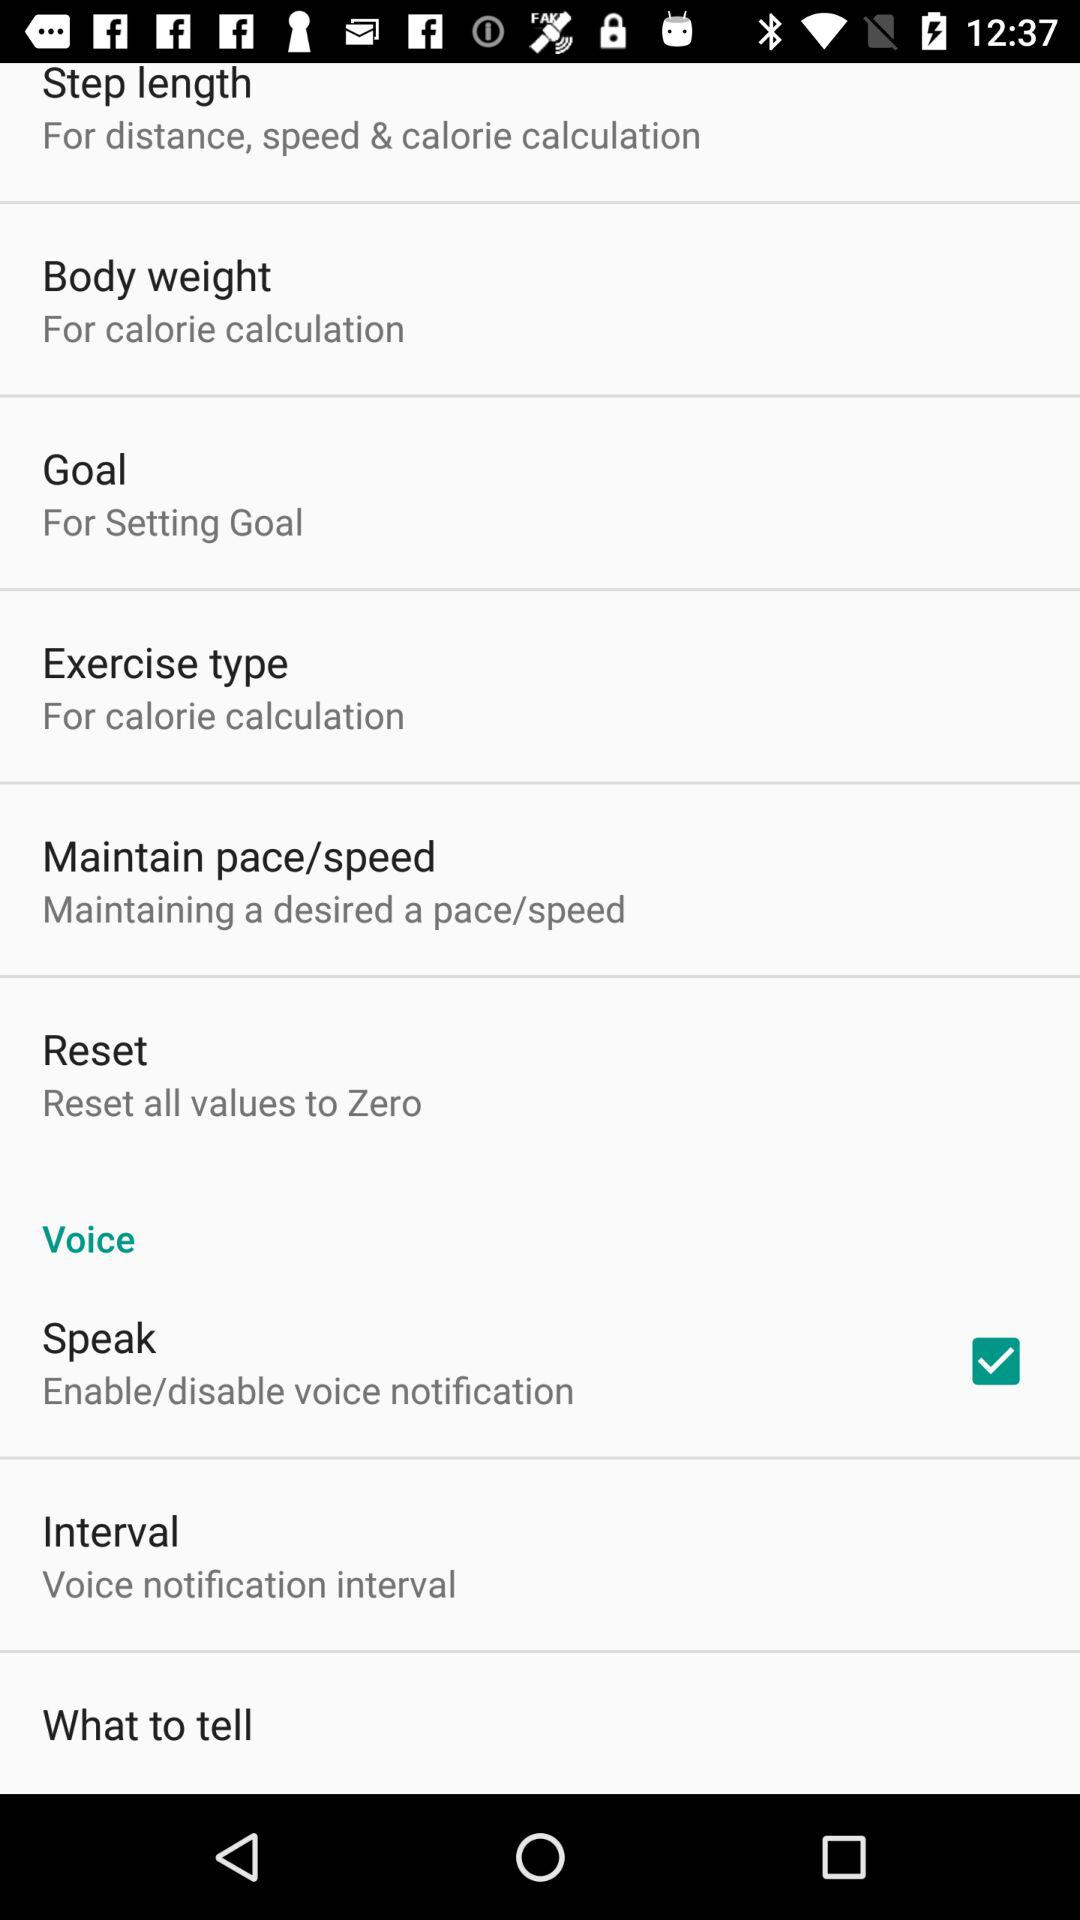How many items are there in the voice settings menu?
Answer the question using a single word or phrase. 3 